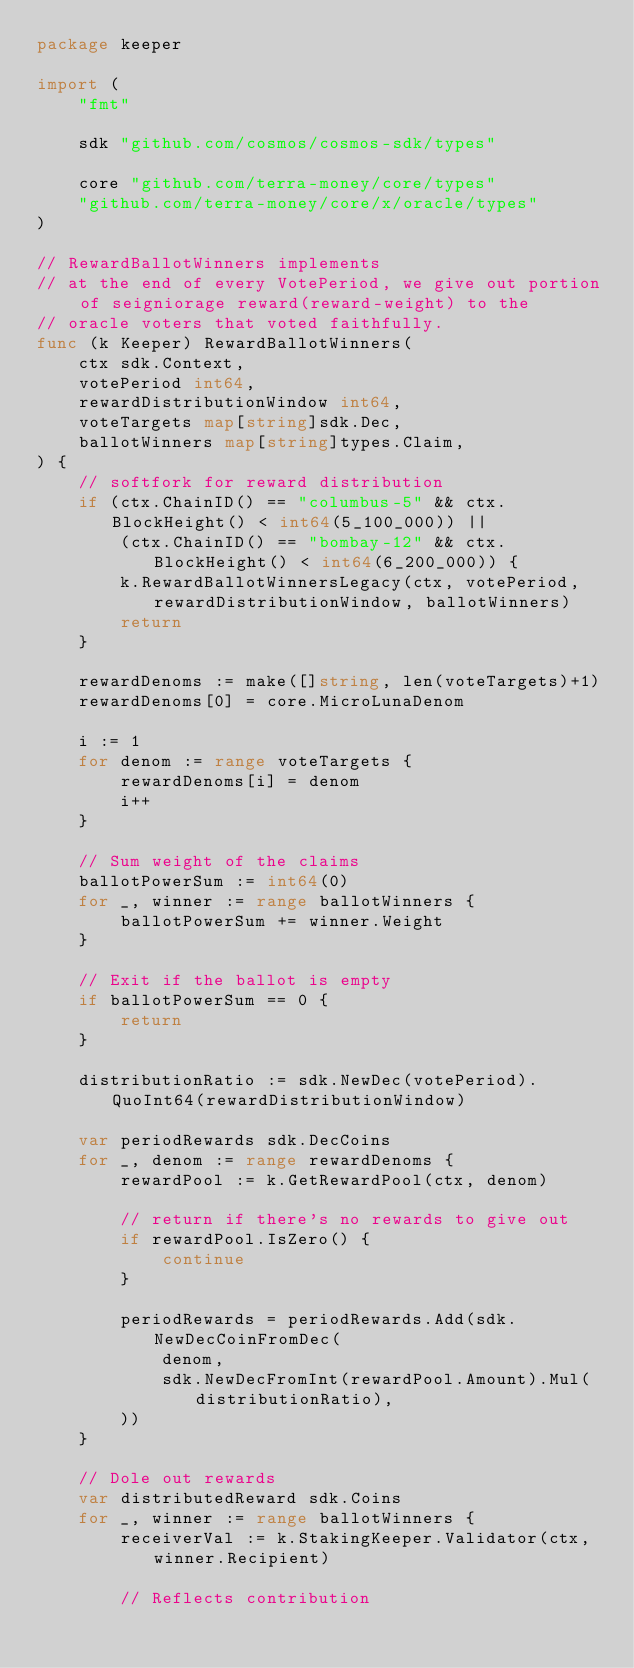Convert code to text. <code><loc_0><loc_0><loc_500><loc_500><_Go_>package keeper

import (
	"fmt"

	sdk "github.com/cosmos/cosmos-sdk/types"

	core "github.com/terra-money/core/types"
	"github.com/terra-money/core/x/oracle/types"
)

// RewardBallotWinners implements
// at the end of every VotePeriod, we give out portion of seigniorage reward(reward-weight) to the
// oracle voters that voted faithfully.
func (k Keeper) RewardBallotWinners(
	ctx sdk.Context,
	votePeriod int64,
	rewardDistributionWindow int64,
	voteTargets map[string]sdk.Dec,
	ballotWinners map[string]types.Claim,
) {
	// softfork for reward distribution
	if (ctx.ChainID() == "columbus-5" && ctx.BlockHeight() < int64(5_100_000)) ||
		(ctx.ChainID() == "bombay-12" && ctx.BlockHeight() < int64(6_200_000)) {
		k.RewardBallotWinnersLegacy(ctx, votePeriod, rewardDistributionWindow, ballotWinners)
		return
	}

	rewardDenoms := make([]string, len(voteTargets)+1)
	rewardDenoms[0] = core.MicroLunaDenom

	i := 1
	for denom := range voteTargets {
		rewardDenoms[i] = denom
		i++
	}

	// Sum weight of the claims
	ballotPowerSum := int64(0)
	for _, winner := range ballotWinners {
		ballotPowerSum += winner.Weight
	}

	// Exit if the ballot is empty
	if ballotPowerSum == 0 {
		return
	}

	distributionRatio := sdk.NewDec(votePeriod).QuoInt64(rewardDistributionWindow)

	var periodRewards sdk.DecCoins
	for _, denom := range rewardDenoms {
		rewardPool := k.GetRewardPool(ctx, denom)

		// return if there's no rewards to give out
		if rewardPool.IsZero() {
			continue
		}

		periodRewards = periodRewards.Add(sdk.NewDecCoinFromDec(
			denom,
			sdk.NewDecFromInt(rewardPool.Amount).Mul(distributionRatio),
		))
	}

	// Dole out rewards
	var distributedReward sdk.Coins
	for _, winner := range ballotWinners {
		receiverVal := k.StakingKeeper.Validator(ctx, winner.Recipient)

		// Reflects contribution</code> 